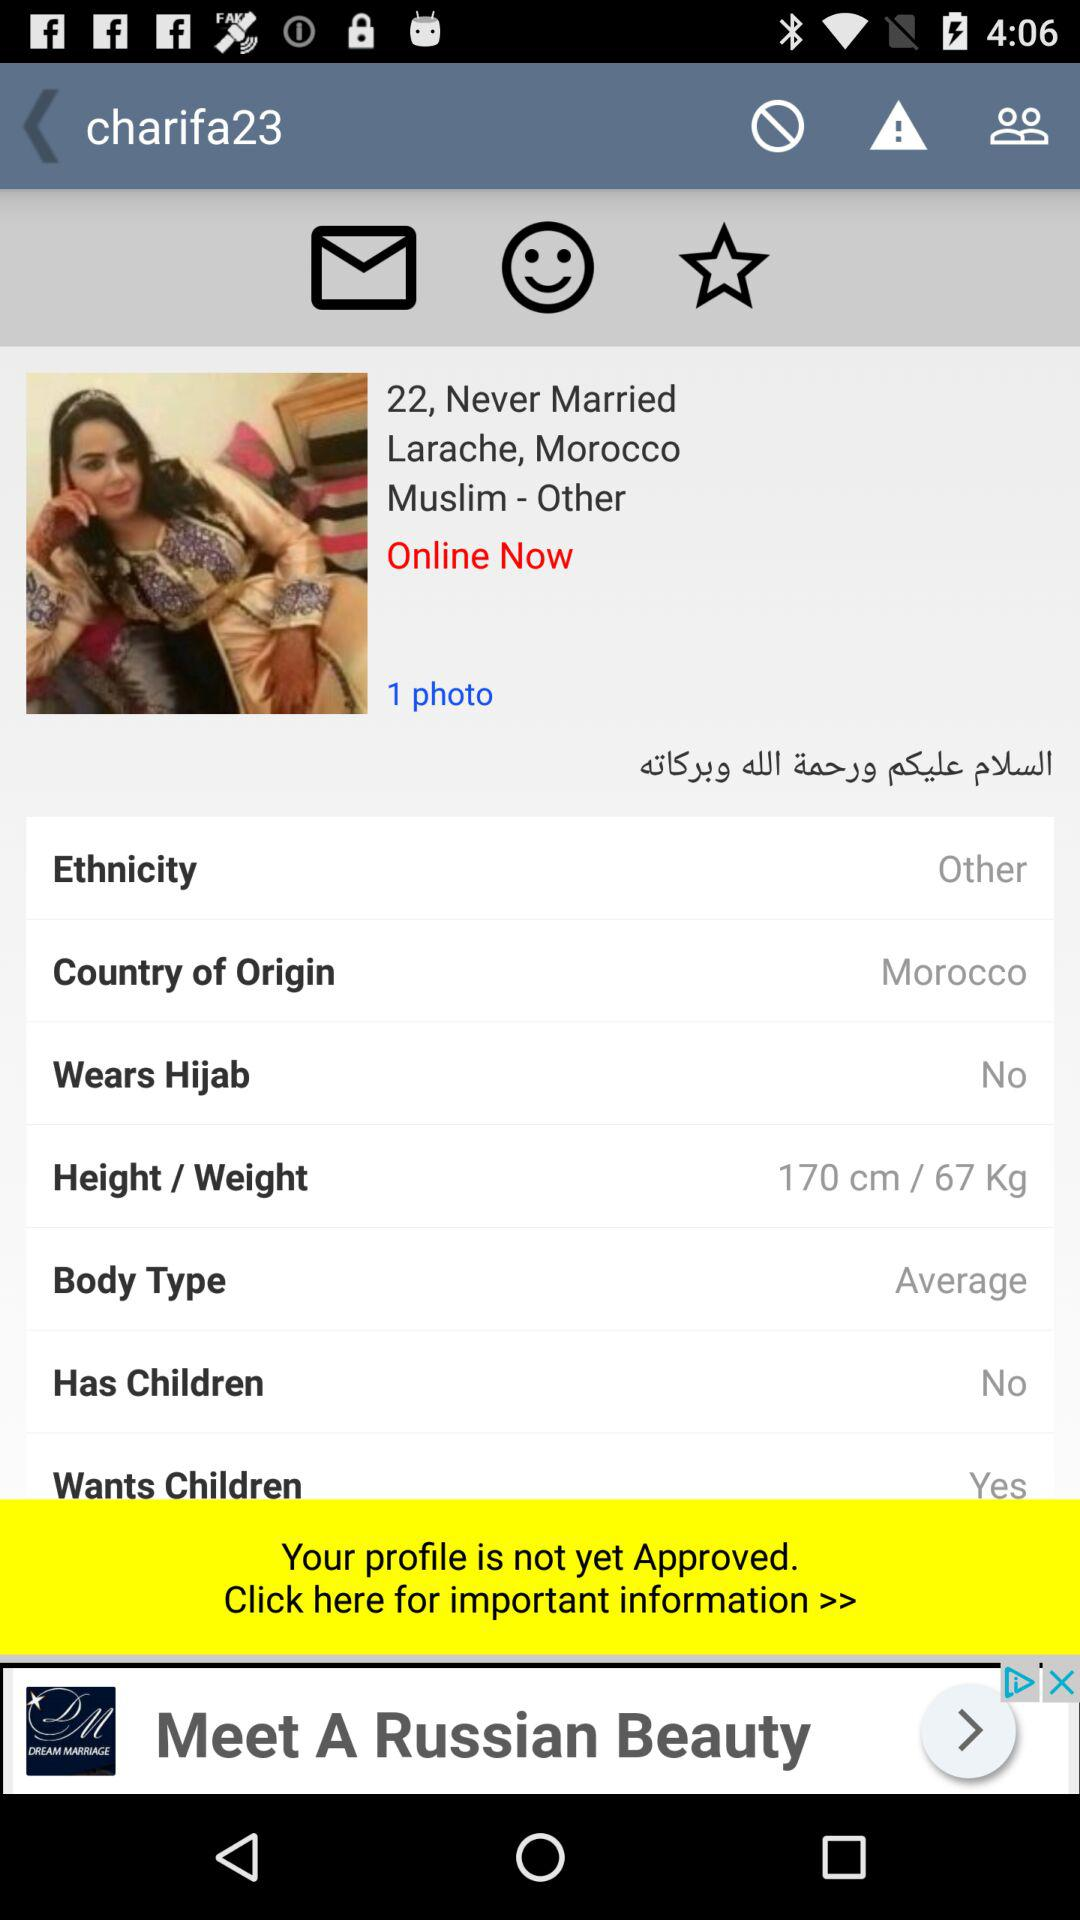What is the age of the user? The user is 22 years old. 